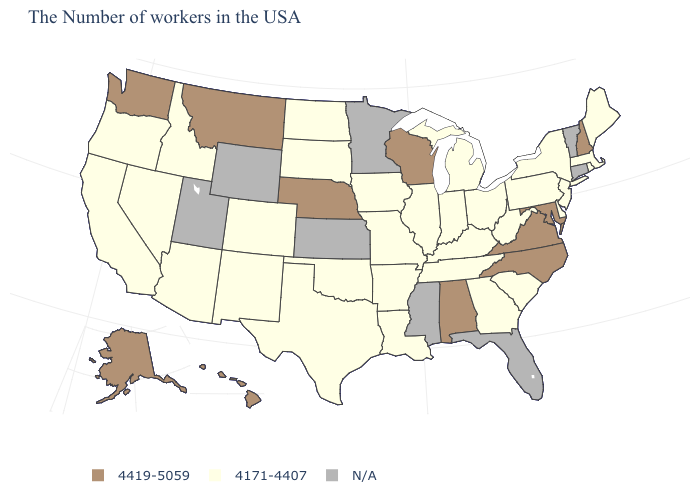Name the states that have a value in the range N/A?
Short answer required. Vermont, Connecticut, Florida, Mississippi, Minnesota, Kansas, Wyoming, Utah. Among the states that border Delaware , does Pennsylvania have the lowest value?
Be succinct. Yes. Which states have the lowest value in the USA?
Write a very short answer. Maine, Massachusetts, Rhode Island, New York, New Jersey, Delaware, Pennsylvania, South Carolina, West Virginia, Ohio, Georgia, Michigan, Kentucky, Indiana, Tennessee, Illinois, Louisiana, Missouri, Arkansas, Iowa, Oklahoma, Texas, South Dakota, North Dakota, Colorado, New Mexico, Arizona, Idaho, Nevada, California, Oregon. What is the value of Utah?
Give a very brief answer. N/A. What is the value of Nebraska?
Concise answer only. 4419-5059. What is the value of Missouri?
Short answer required. 4171-4407. What is the lowest value in states that border Mississippi?
Answer briefly. 4171-4407. Does Washington have the highest value in the USA?
Short answer required. Yes. What is the value of Louisiana?
Answer briefly. 4171-4407. Which states hav the highest value in the MidWest?
Concise answer only. Wisconsin, Nebraska. What is the highest value in states that border Nevada?
Give a very brief answer. 4171-4407. What is the lowest value in states that border Massachusetts?
Be succinct. 4171-4407. How many symbols are there in the legend?
Be succinct. 3. 